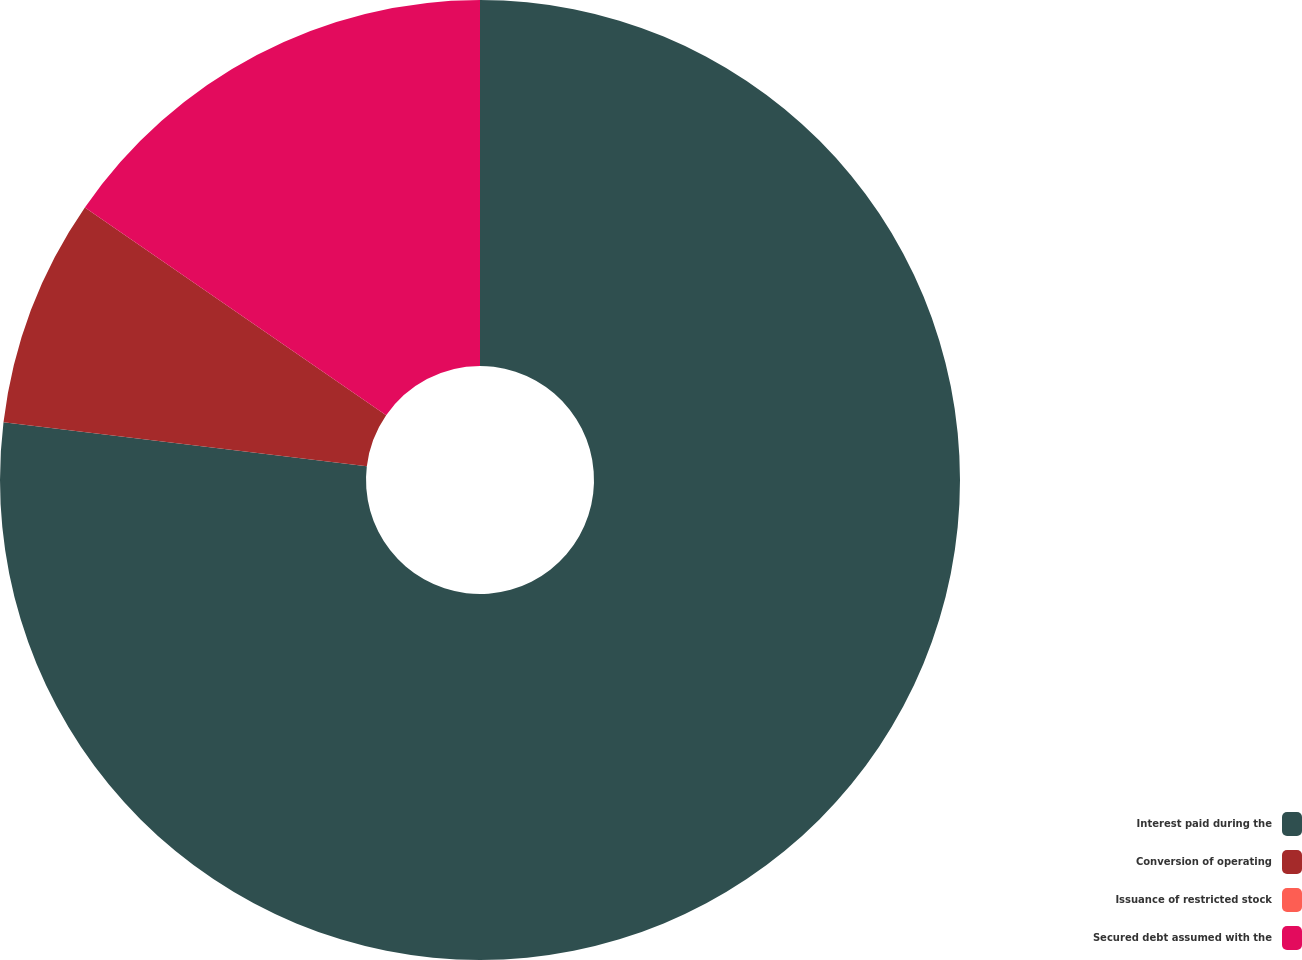Convert chart to OTSL. <chart><loc_0><loc_0><loc_500><loc_500><pie_chart><fcel>Interest paid during the<fcel>Conversion of operating<fcel>Issuance of restricted stock<fcel>Secured debt assumed with the<nl><fcel>76.92%<fcel>7.69%<fcel>0.0%<fcel>15.39%<nl></chart> 